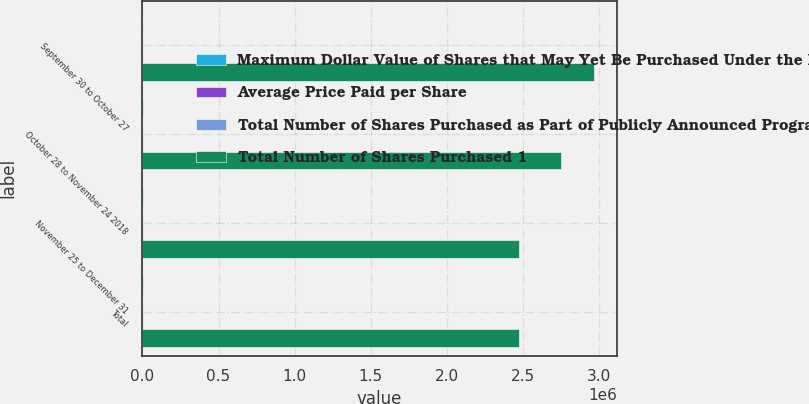Convert chart to OTSL. <chart><loc_0><loc_0><loc_500><loc_500><stacked_bar_chart><ecel><fcel>September 30 to October 27<fcel>October 28 to November 24 2018<fcel>November 25 to December 31<fcel>Total<nl><fcel>Maximum Dollar Value of Shares that May Yet Be Purchased Under the Programs 2<fcel>128<fcel>1126<fcel>1466<fcel>2720<nl><fcel>Average Price Paid per Share<fcel>182.79<fcel>195.56<fcel>189.54<fcel>191.71<nl><fcel>Total Number of Shares Purchased as Part of Publicly Announced Programs 2<fcel>128<fcel>1126<fcel>1460<fcel>2714<nl><fcel>Total Number of Shares Purchased 1<fcel>2.96868e+06<fcel>2.74848e+06<fcel>2.47178e+06<fcel>2.47178e+06<nl></chart> 